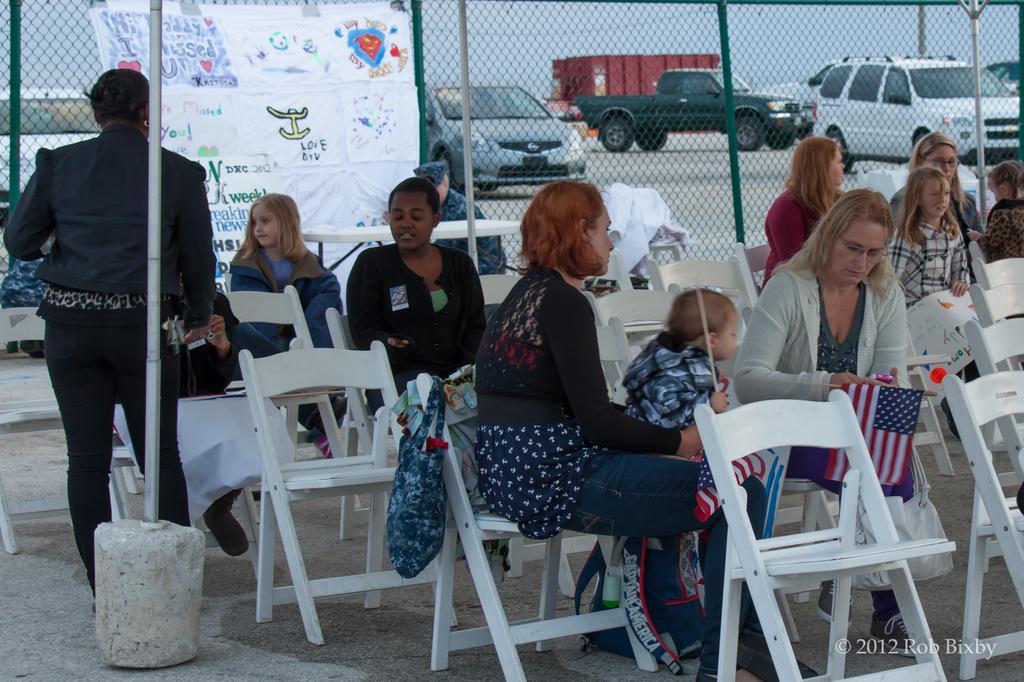Describe this image in one or two sentences. In this image there are few persons are sitting on the chairs. Person is standing at the left side of image is wearing a black shirt. A banner is attached to the fence. Backside of the fence there are few cars on the road. Front side there is a woman sitting on a chair is holding a baby. A bag is hanging on a chair. 